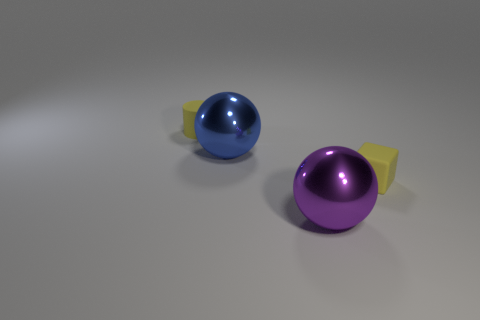What number of yellow matte things are the same shape as the purple shiny object?
Ensure brevity in your answer.  0. What is the material of the small cube?
Offer a terse response. Rubber. Does the blue shiny object have the same shape as the purple thing?
Make the answer very short. Yes. Is there another tiny yellow cylinder made of the same material as the small cylinder?
Ensure brevity in your answer.  No. What is the color of the object that is both left of the yellow block and on the right side of the large blue metal object?
Ensure brevity in your answer.  Purple. There is a tiny thing right of the large purple metallic sphere; what is it made of?
Offer a very short reply. Rubber. Are there any tiny yellow things that have the same shape as the blue object?
Offer a terse response. No. What number of other objects are there of the same shape as the blue metal object?
Offer a very short reply. 1. There is a purple shiny thing; does it have the same shape as the yellow thing right of the blue ball?
Provide a short and direct response. No. Are there any other things that are the same material as the yellow cylinder?
Your answer should be very brief. Yes. 